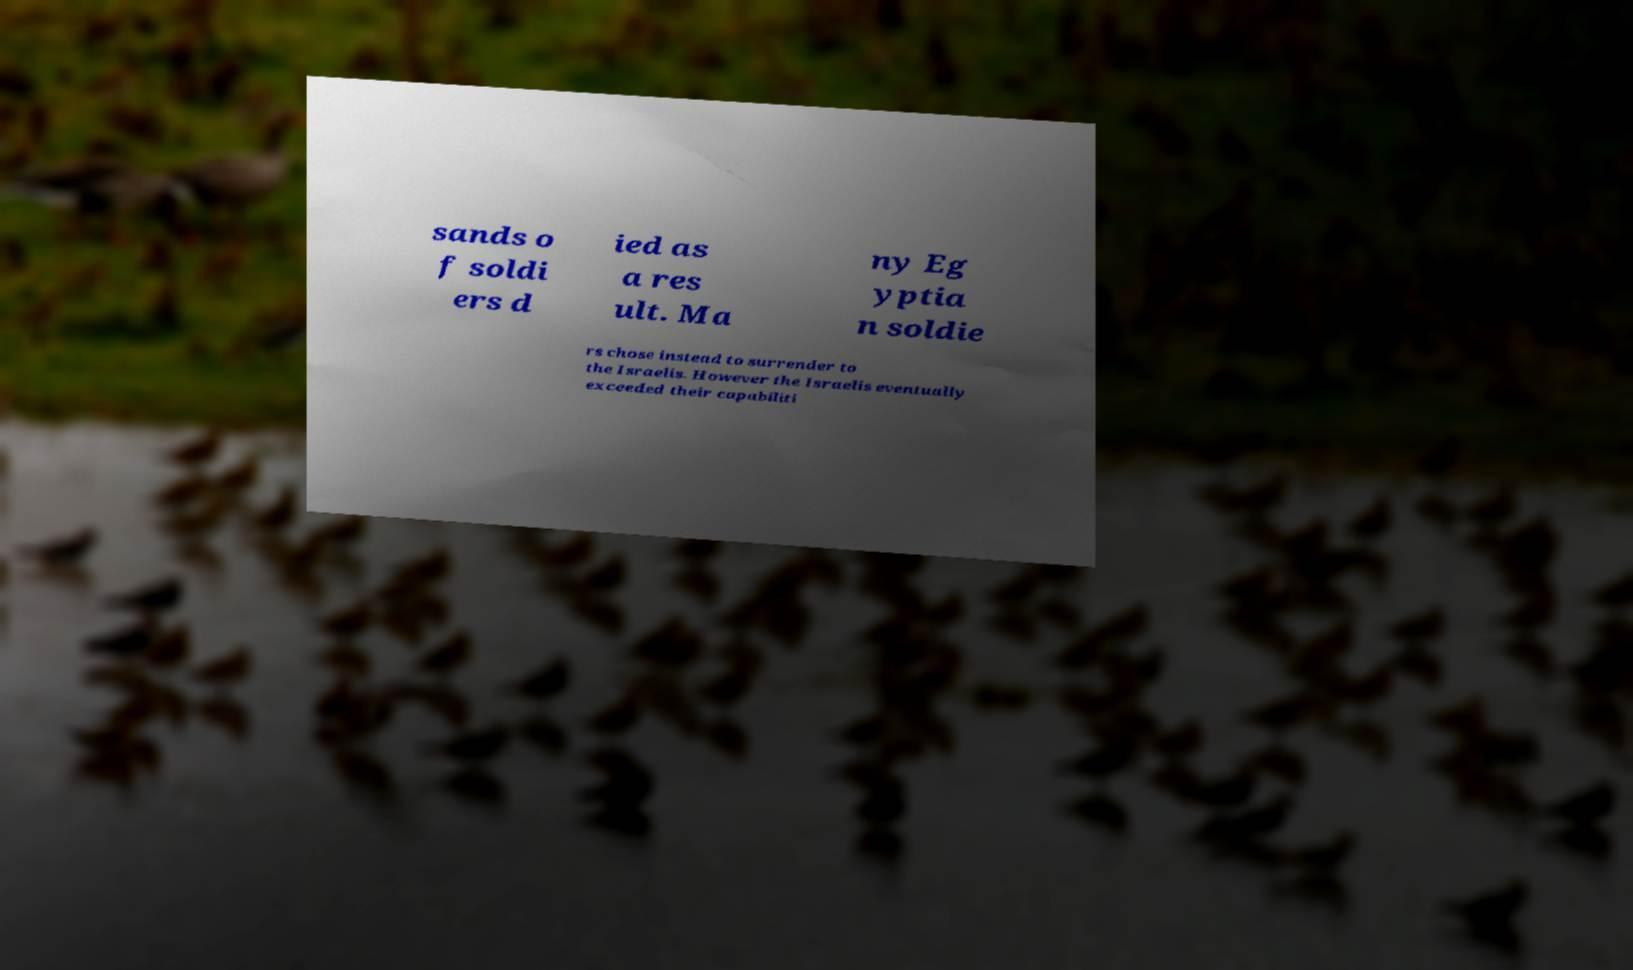Can you accurately transcribe the text from the provided image for me? sands o f soldi ers d ied as a res ult. Ma ny Eg yptia n soldie rs chose instead to surrender to the Israelis. However the Israelis eventually exceeded their capabiliti 